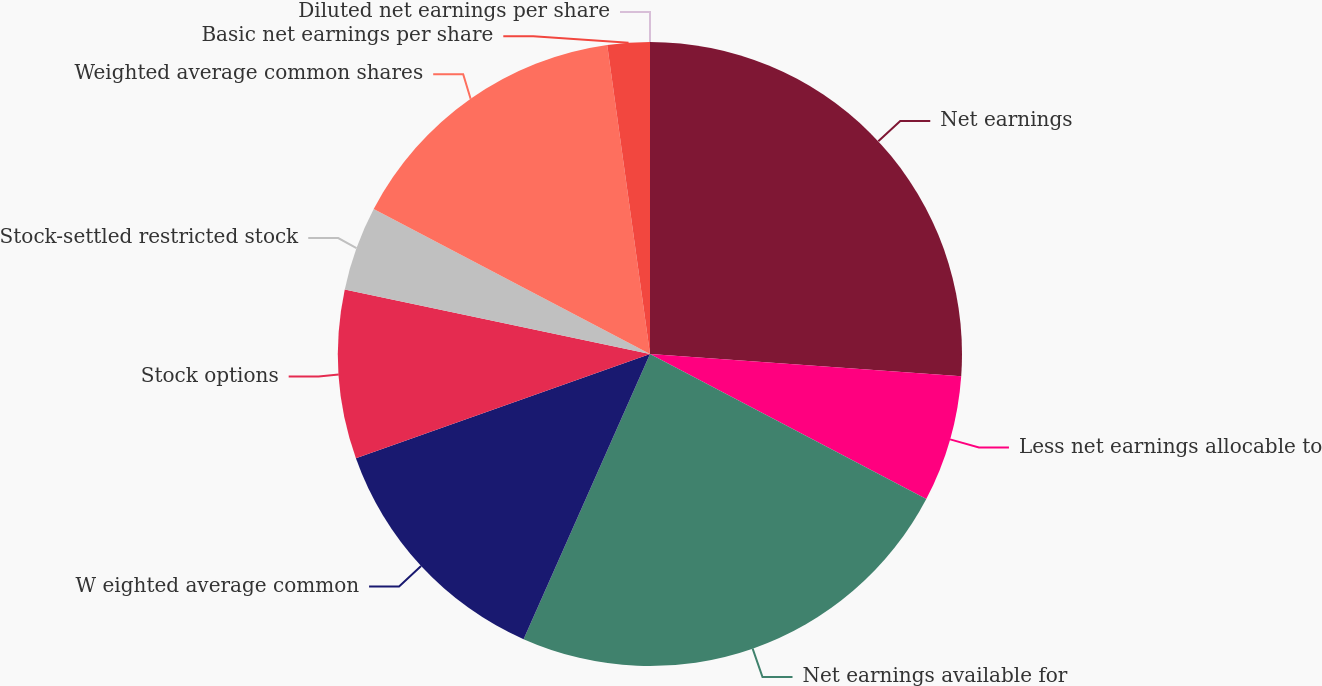Convert chart to OTSL. <chart><loc_0><loc_0><loc_500><loc_500><pie_chart><fcel>Net earnings<fcel>Less net earnings allocable to<fcel>Net earnings available for<fcel>W eighted average common<fcel>Stock options<fcel>Stock-settled restricted stock<fcel>Weighted average common shares<fcel>Basic net earnings per share<fcel>Diluted net earnings per share<nl><fcel>26.13%<fcel>6.56%<fcel>23.95%<fcel>12.94%<fcel>8.74%<fcel>4.37%<fcel>15.12%<fcel>2.19%<fcel>0.0%<nl></chart> 